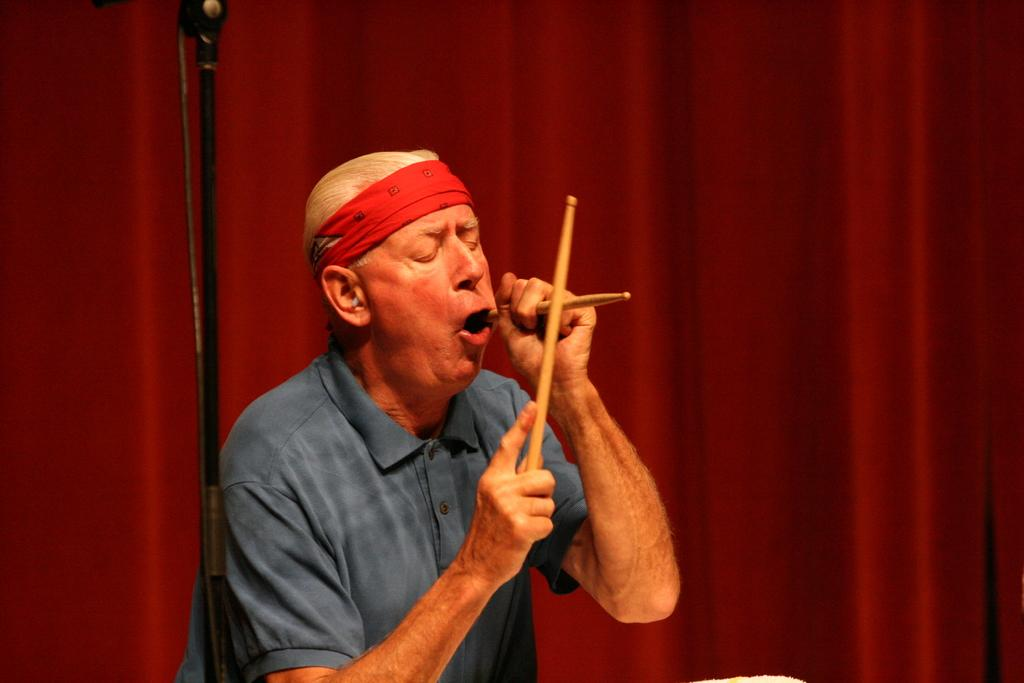Who or what is in the image? There is a person present in the image. What is the person holding in the image? The person is holding two sticks. What is the person wearing in the image? The person is wearing a blue color shirt. What can be seen in the background of the image? There is a red curtain in the background of the image. What type of fish can be seen swimming behind the person in the image? There is no fish present in the image; it only features a person holding two sticks and wearing a blue shirt, with a red curtain in the background. 